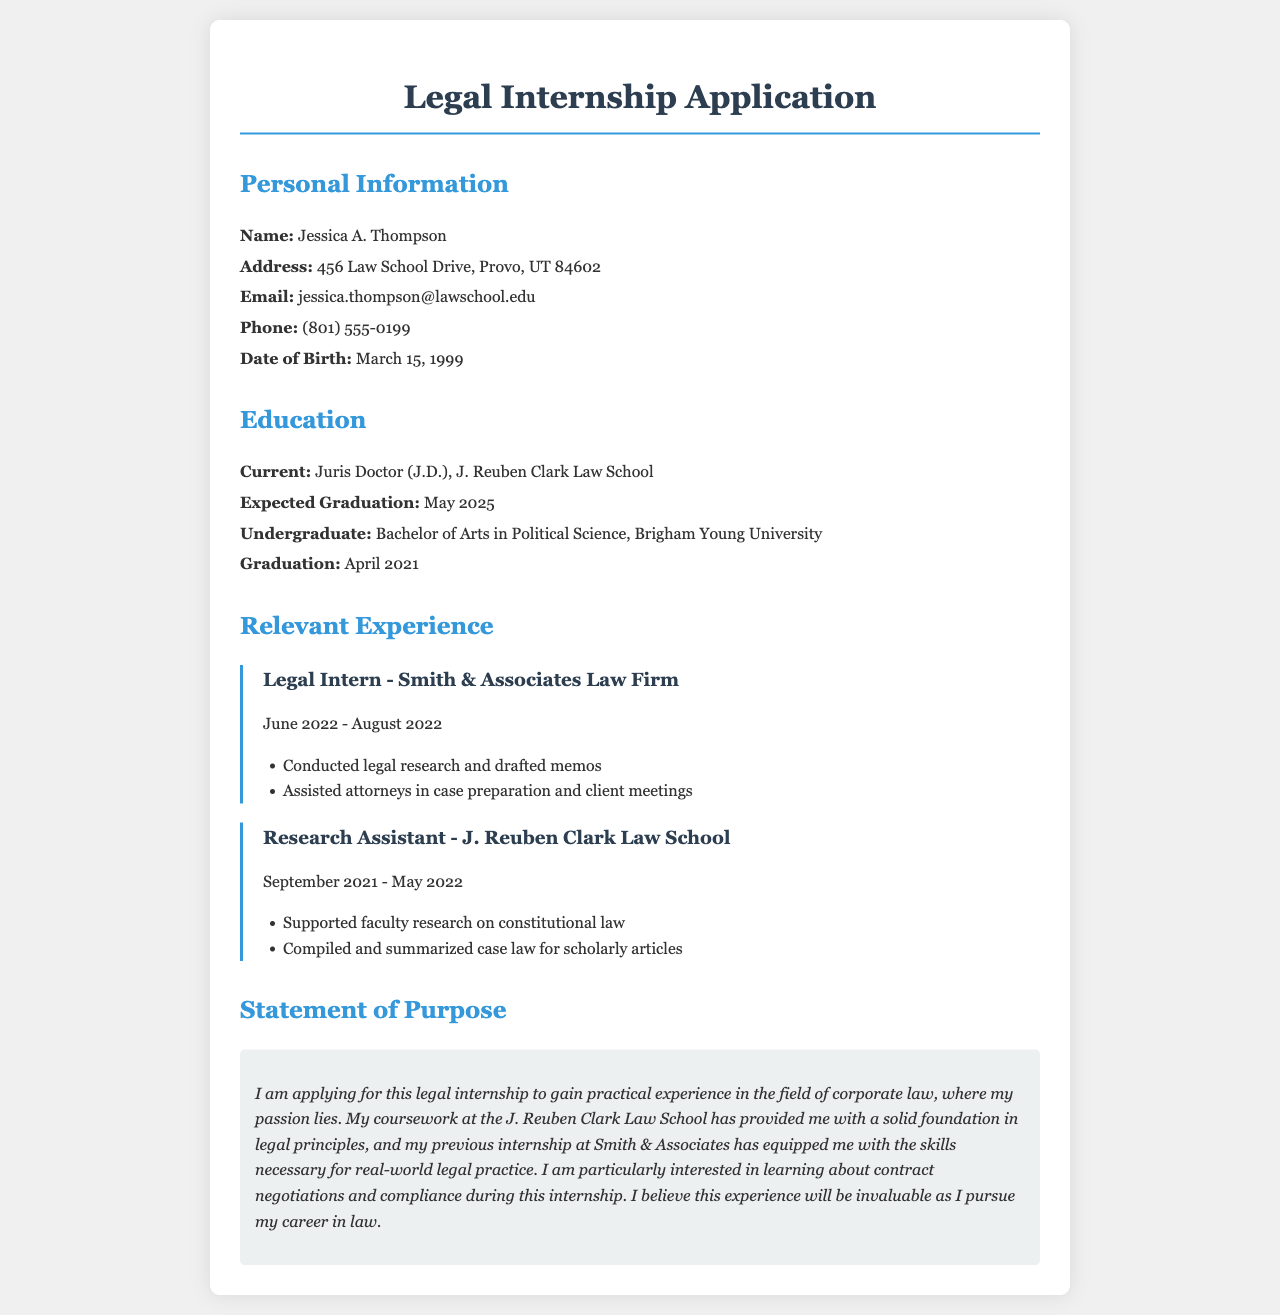What is the applicant's name? The name of the applicant is specified in the personal information section as Jessica A. Thompson.
Answer: Jessica A. Thompson What is the applicant's date of birth? The date of birth can be found in the personal information section, which lists it as March 15, 1999.
Answer: March 15, 1999 What degree is the applicant currently pursuing? The applicant is pursuing a Juris Doctor (J.D.) at the J. Reuben Clark Law School as mentioned in the education section.
Answer: Juris Doctor (J.D.) What was the duration of the applicant's internship at Smith & Associates Law Firm? The duration of the internship is specified as June 2022 to August 2022, which indicates a two-month period.
Answer: June 2022 - August 2022 What specific area of law is the applicant interested in for the internship? The statement of purpose indicates the applicant's interest in corporate law.
Answer: Corporate law How has the applicant's previous experience prepared them for this internship? The applicant states that their previous internship at Smith & Associates has equipped them with necessary skills for real-world legal practice.
Answer: Equipped with necessary skills What was the applicant's undergraduate major? The educational background mentions that the applicant received a Bachelor of Arts in Political Science.
Answer: Political Science What specific skills did the applicant develop during their Research Assistant position? The document notes that the applicant compiled and summarized case law relevant to scholarly articles while in this role.
Answer: Compiled and summarized case law What is the applicant's expected graduation date? The expected graduation date can be found in the education section, noting it as May 2025.
Answer: May 2025 